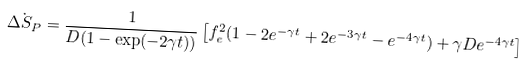<formula> <loc_0><loc_0><loc_500><loc_500>\dot { \Delta S _ { P } } = \frac { 1 } { D ( 1 - \exp ( - 2 \gamma t ) ) } \left [ f _ { e } ^ { 2 } ( 1 - 2 e ^ { - \gamma t } + 2 e ^ { - 3 \gamma t } - e ^ { - 4 \gamma t } ) + \gamma D e ^ { - 4 \gamma t } \right ]</formula> 